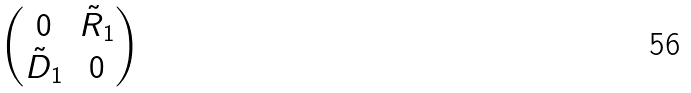Convert formula to latex. <formula><loc_0><loc_0><loc_500><loc_500>\begin{pmatrix} 0 & \tilde { R } _ { 1 } \\ \tilde { D } _ { 1 } & 0 \end{pmatrix}</formula> 